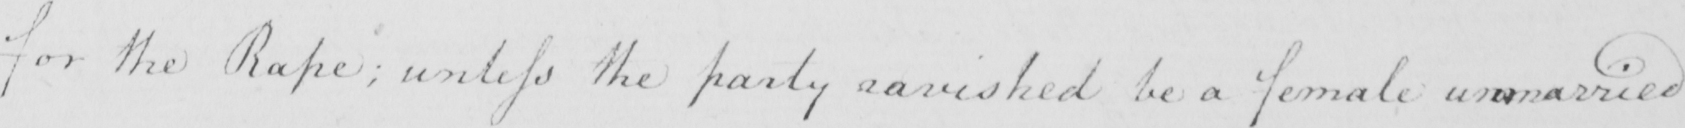Please provide the text content of this handwritten line. for the Rape ; unless the party ravished be a female unmarried 